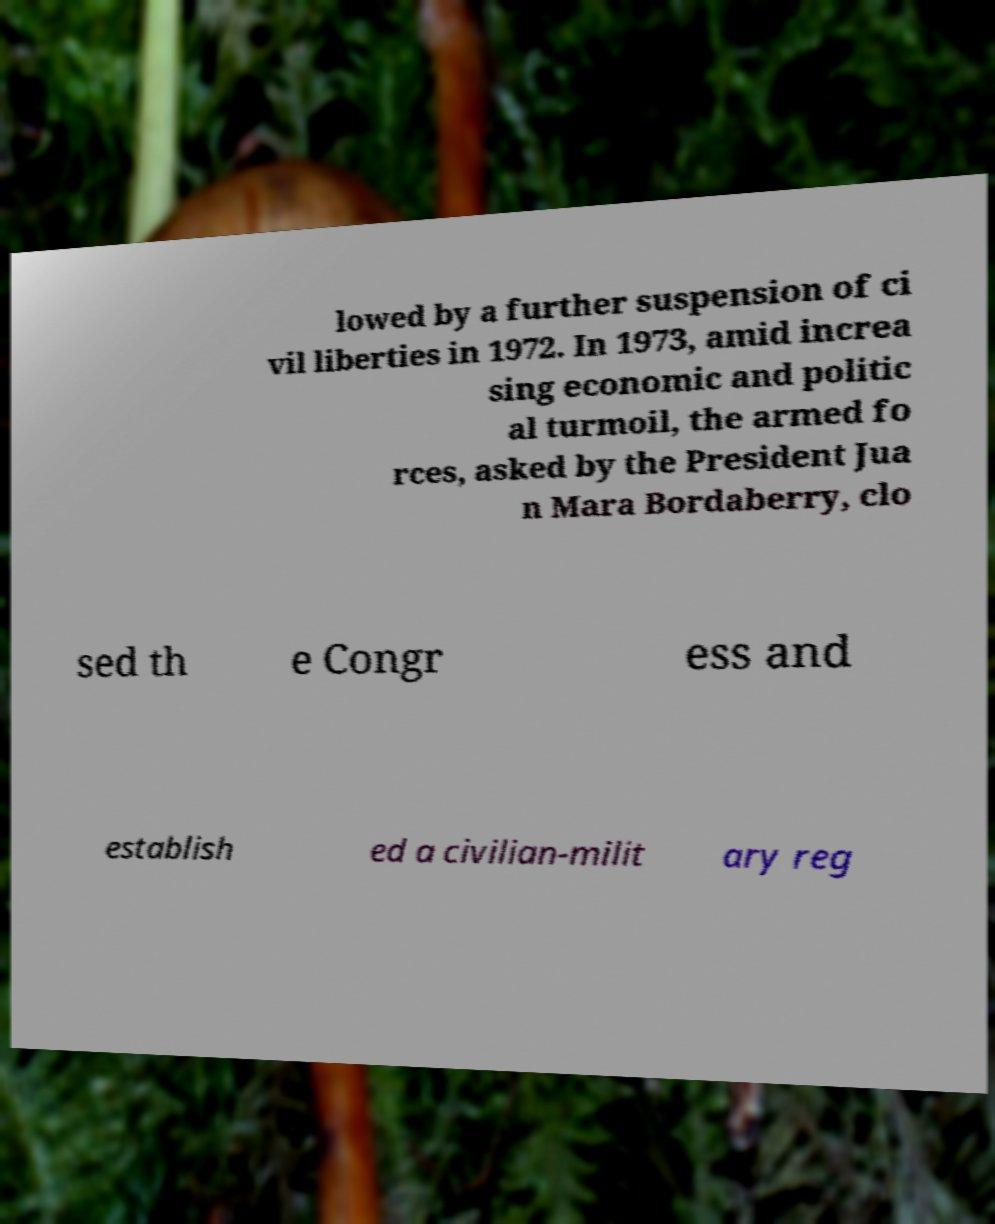What messages or text are displayed in this image? I need them in a readable, typed format. lowed by a further suspension of ci vil liberties in 1972. In 1973, amid increa sing economic and politic al turmoil, the armed fo rces, asked by the President Jua n Mara Bordaberry, clo sed th e Congr ess and establish ed a civilian-milit ary reg 